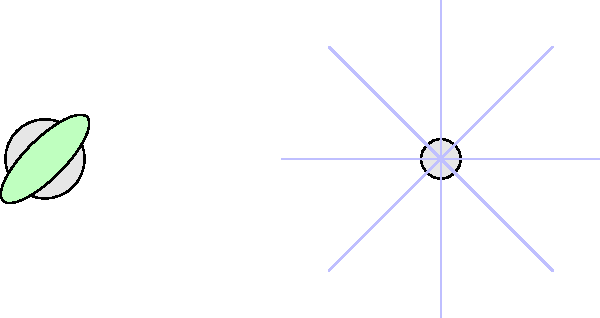As a woodcut printmaker inspired by nature's intricacies, you're creating a series on seed dispersal mechanisms. Which of the depicted seed types (A, B, or C) would likely travel the farthest distance from its parent plant in a gentle breeze, and why? To answer this question, we need to consider the biomechanical properties of each seed type:

1. Seed A (Maple seed):
   - Has a wing-like structure
   - Utilizes autorotation for dispersal
   - Creates lift and reduces falling speed

2. Seed B (Dandelion seed):
   - Has multiple fine, hair-like structures (pappus)
   - Creates high air resistance
   - Utilizes wind for dispersal

3. Seed C (Coconut):
   - Large and heavy
   - No specialized structures for wind dispersal
   - Primarily dispersed by water or gravity

Comparing the seeds:
- Seed A can travel moderate distances due to its autorotation mechanism.
- Seed B is the lightest and has the highest surface area-to-mass ratio, allowing it to be carried easily by wind.
- Seed C is too heavy for wind dispersal and would fall straight down.

In a gentle breeze:
- Seed B would travel the farthest due to its lightweight nature and high air resistance.
- Seed A would travel a moderate distance.
- Seed C would not be affected by the breeze.

Therefore, the dandelion seed (B) would likely travel the farthest distance from its parent plant in a gentle breeze due to its lightweight structure and high surface area-to-mass ratio, which maximizes its interaction with air currents.
Answer: B (Dandelion seed) 